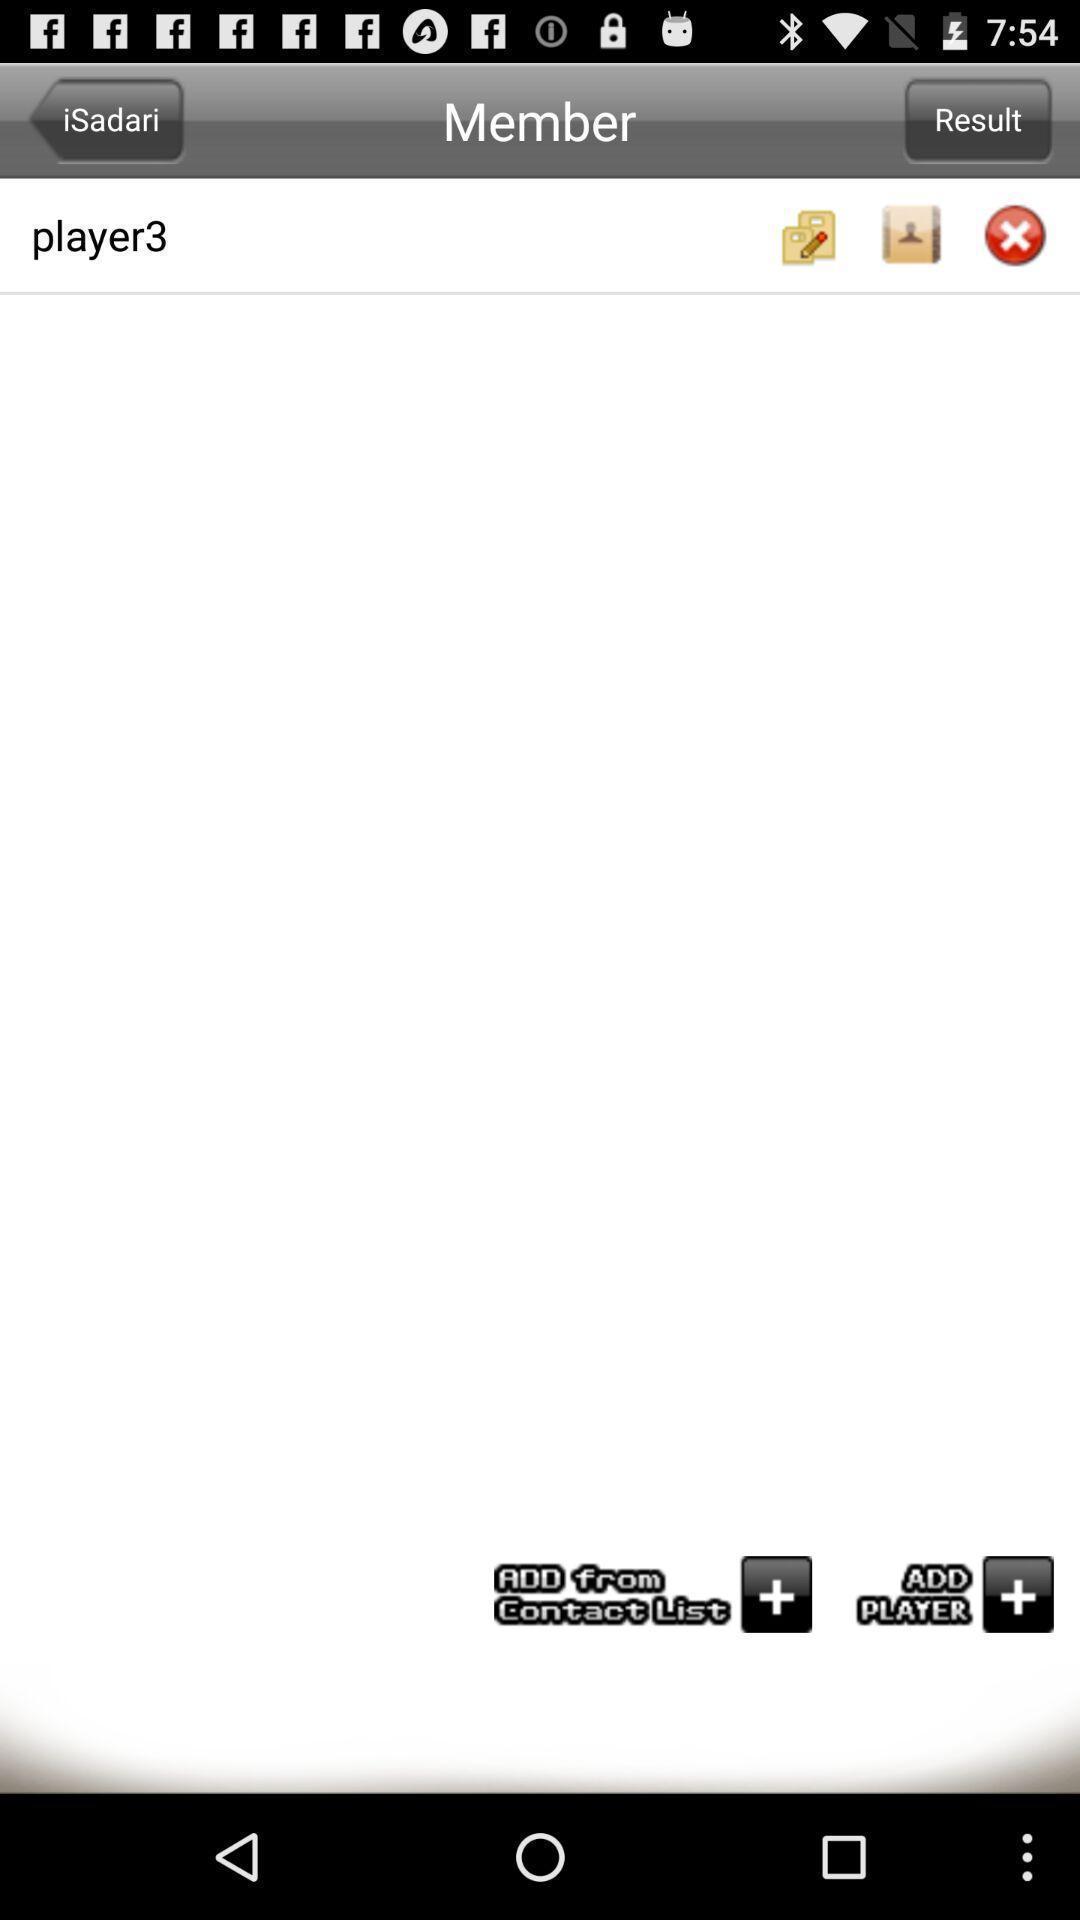What details can you identify in this image? Page displaying member information. 